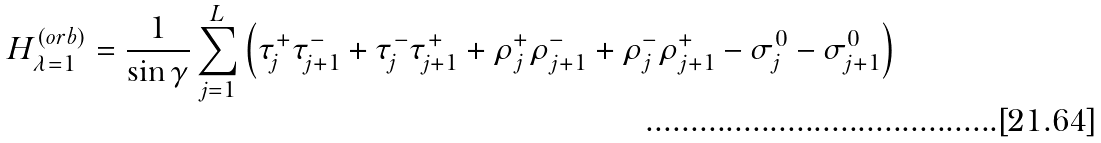Convert formula to latex. <formula><loc_0><loc_0><loc_500><loc_500>H ^ { ( o r b ) } _ { \lambda = 1 } = \frac { 1 } { \sin \gamma } \sum ^ { L } _ { j = 1 } \left ( \tau ^ { + } _ { j } \tau ^ { - } _ { j + 1 } + \tau ^ { - } _ { j } \tau ^ { + } _ { j + 1 } + \rho ^ { + } _ { j } \rho ^ { - } _ { j + 1 } + \rho ^ { - } _ { j } \rho ^ { + } _ { j + 1 } - \sigma ^ { 0 } _ { j } - \sigma ^ { 0 } _ { j + 1 } \right )</formula> 